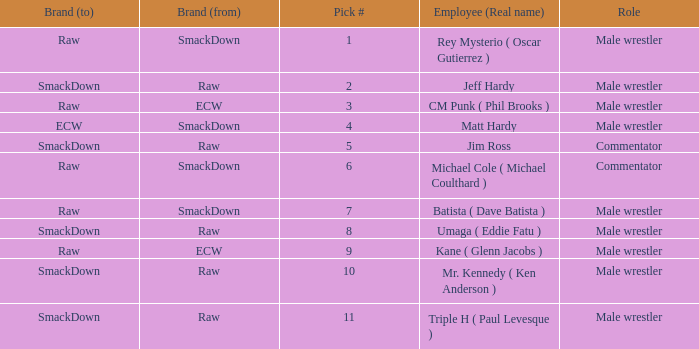What is the real name of the Pick # that is greater than 9? Mr. Kennedy ( Ken Anderson ), Triple H ( Paul Levesque ). 